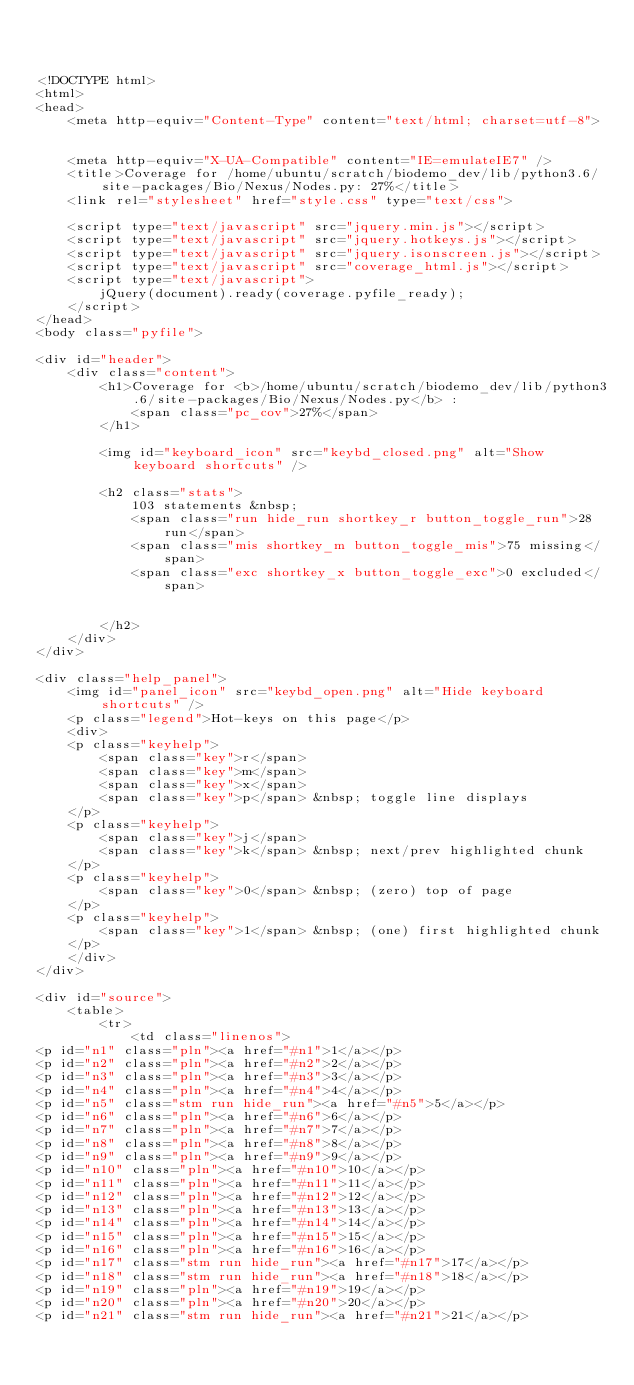<code> <loc_0><loc_0><loc_500><loc_500><_HTML_>


<!DOCTYPE html>
<html>
<head>
    <meta http-equiv="Content-Type" content="text/html; charset=utf-8">
    
    
    <meta http-equiv="X-UA-Compatible" content="IE=emulateIE7" />
    <title>Coverage for /home/ubuntu/scratch/biodemo_dev/lib/python3.6/site-packages/Bio/Nexus/Nodes.py: 27%</title>
    <link rel="stylesheet" href="style.css" type="text/css">
    
    <script type="text/javascript" src="jquery.min.js"></script>
    <script type="text/javascript" src="jquery.hotkeys.js"></script>
    <script type="text/javascript" src="jquery.isonscreen.js"></script>
    <script type="text/javascript" src="coverage_html.js"></script>
    <script type="text/javascript">
        jQuery(document).ready(coverage.pyfile_ready);
    </script>
</head>
<body class="pyfile">

<div id="header">
    <div class="content">
        <h1>Coverage for <b>/home/ubuntu/scratch/biodemo_dev/lib/python3.6/site-packages/Bio/Nexus/Nodes.py</b> :
            <span class="pc_cov">27%</span>
        </h1>

        <img id="keyboard_icon" src="keybd_closed.png" alt="Show keyboard shortcuts" />

        <h2 class="stats">
            103 statements &nbsp;
            <span class="run hide_run shortkey_r button_toggle_run">28 run</span>
            <span class="mis shortkey_m button_toggle_mis">75 missing</span>
            <span class="exc shortkey_x button_toggle_exc">0 excluded</span>

            
        </h2>
    </div>
</div>

<div class="help_panel">
    <img id="panel_icon" src="keybd_open.png" alt="Hide keyboard shortcuts" />
    <p class="legend">Hot-keys on this page</p>
    <div>
    <p class="keyhelp">
        <span class="key">r</span>
        <span class="key">m</span>
        <span class="key">x</span>
        <span class="key">p</span> &nbsp; toggle line displays
    </p>
    <p class="keyhelp">
        <span class="key">j</span>
        <span class="key">k</span> &nbsp; next/prev highlighted chunk
    </p>
    <p class="keyhelp">
        <span class="key">0</span> &nbsp; (zero) top of page
    </p>
    <p class="keyhelp">
        <span class="key">1</span> &nbsp; (one) first highlighted chunk
    </p>
    </div>
</div>

<div id="source">
    <table>
        <tr>
            <td class="linenos">
<p id="n1" class="pln"><a href="#n1">1</a></p>
<p id="n2" class="pln"><a href="#n2">2</a></p>
<p id="n3" class="pln"><a href="#n3">3</a></p>
<p id="n4" class="pln"><a href="#n4">4</a></p>
<p id="n5" class="stm run hide_run"><a href="#n5">5</a></p>
<p id="n6" class="pln"><a href="#n6">6</a></p>
<p id="n7" class="pln"><a href="#n7">7</a></p>
<p id="n8" class="pln"><a href="#n8">8</a></p>
<p id="n9" class="pln"><a href="#n9">9</a></p>
<p id="n10" class="pln"><a href="#n10">10</a></p>
<p id="n11" class="pln"><a href="#n11">11</a></p>
<p id="n12" class="pln"><a href="#n12">12</a></p>
<p id="n13" class="pln"><a href="#n13">13</a></p>
<p id="n14" class="pln"><a href="#n14">14</a></p>
<p id="n15" class="pln"><a href="#n15">15</a></p>
<p id="n16" class="pln"><a href="#n16">16</a></p>
<p id="n17" class="stm run hide_run"><a href="#n17">17</a></p>
<p id="n18" class="stm run hide_run"><a href="#n18">18</a></p>
<p id="n19" class="pln"><a href="#n19">19</a></p>
<p id="n20" class="pln"><a href="#n20">20</a></p>
<p id="n21" class="stm run hide_run"><a href="#n21">21</a></p></code> 